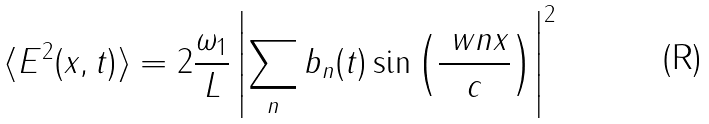Convert formula to latex. <formula><loc_0><loc_0><loc_500><loc_500>\langle E ^ { 2 } ( x , t ) \rangle = 2 \frac { \omega _ { 1 } } L \left | \sum _ { n } b _ { n } ( t ) \sin \left ( \frac { \ w n x } c \right ) \right | ^ { 2 }</formula> 